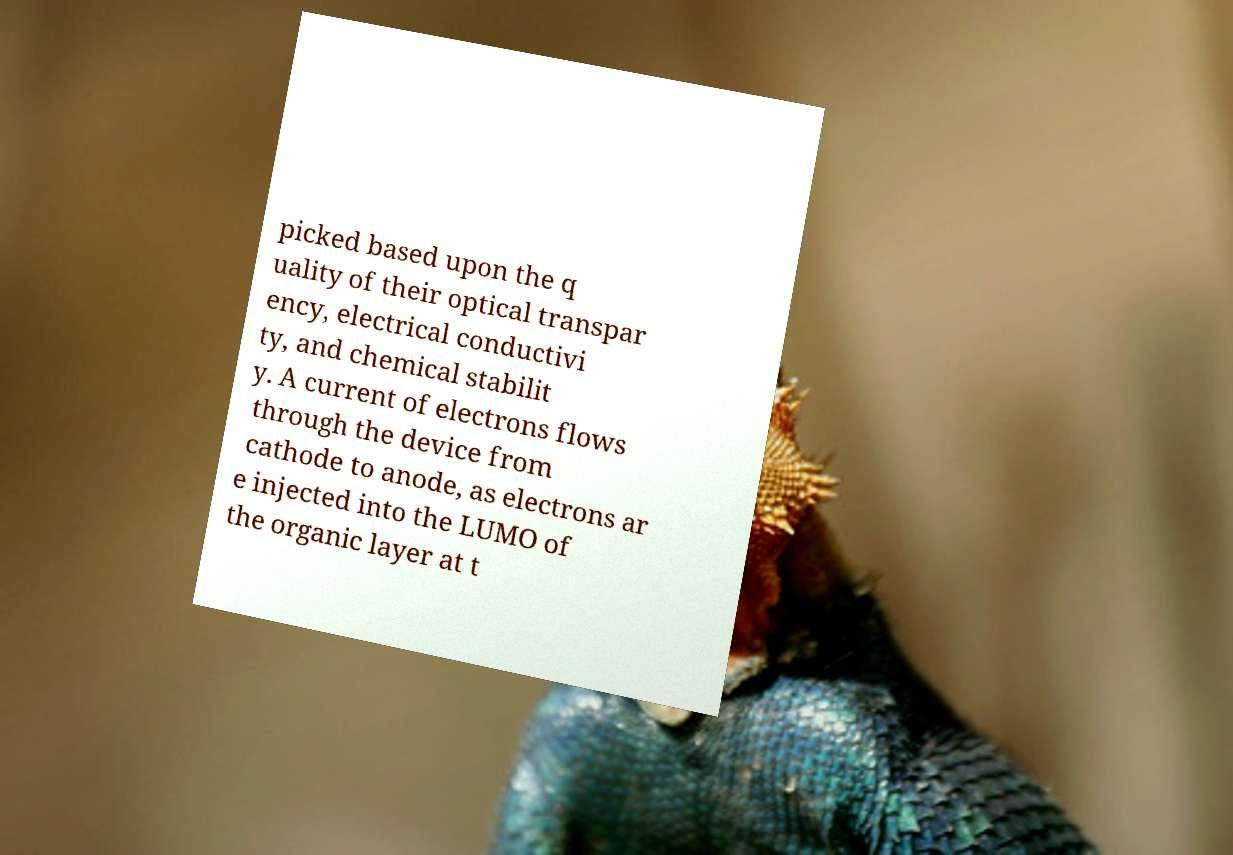Can you accurately transcribe the text from the provided image for me? picked based upon the q uality of their optical transpar ency, electrical conductivi ty, and chemical stabilit y. A current of electrons flows through the device from cathode to anode, as electrons ar e injected into the LUMO of the organic layer at t 